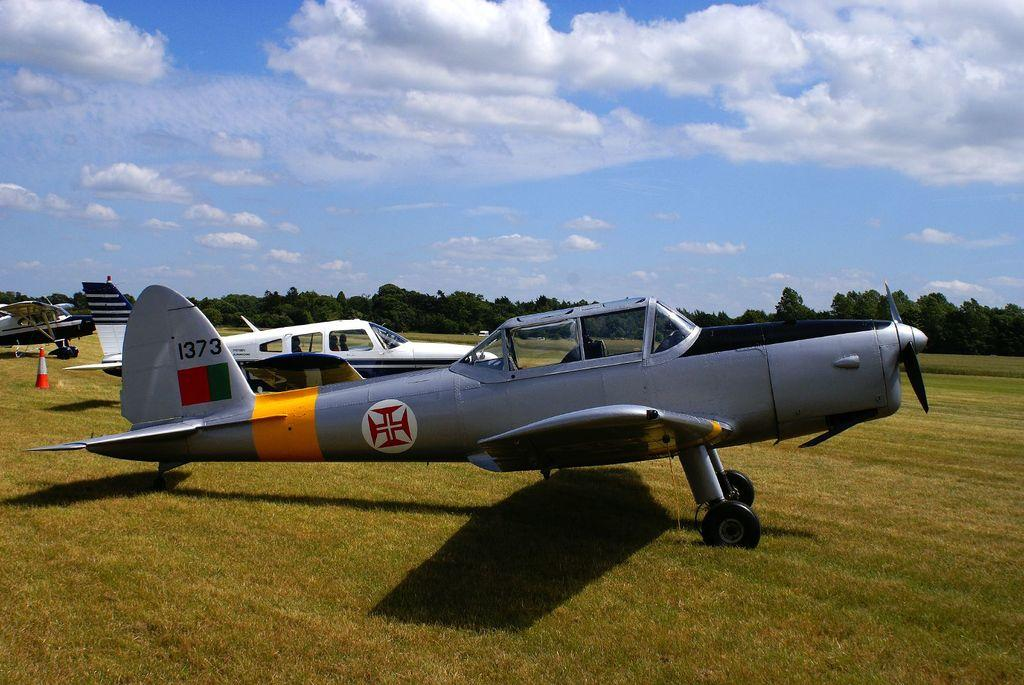<image>
Summarize the visual content of the image. A grey fighter jet sits on a grass field with the numbers 1373 on its tail wing 